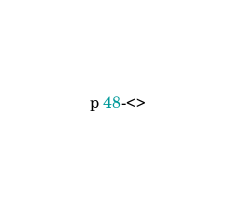Convert code to text. <code><loc_0><loc_0><loc_500><loc_500><_Perl_>p 48-<></code> 